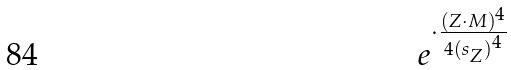<formula> <loc_0><loc_0><loc_500><loc_500>e ^ { \cdot \frac { ( Z \cdot M ) ^ { 4 } } { 4 { ( s _ { Z } ) } ^ { 4 } } }</formula> 